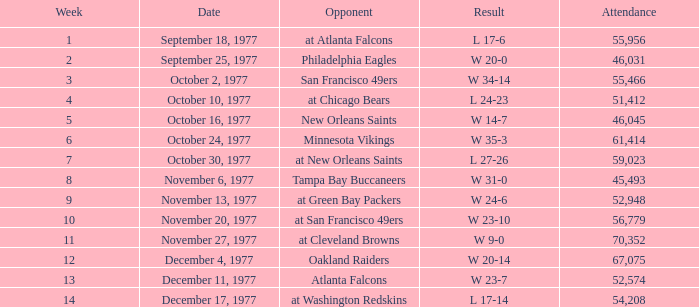What is the lowest attendance for week 2? 46031.0. 